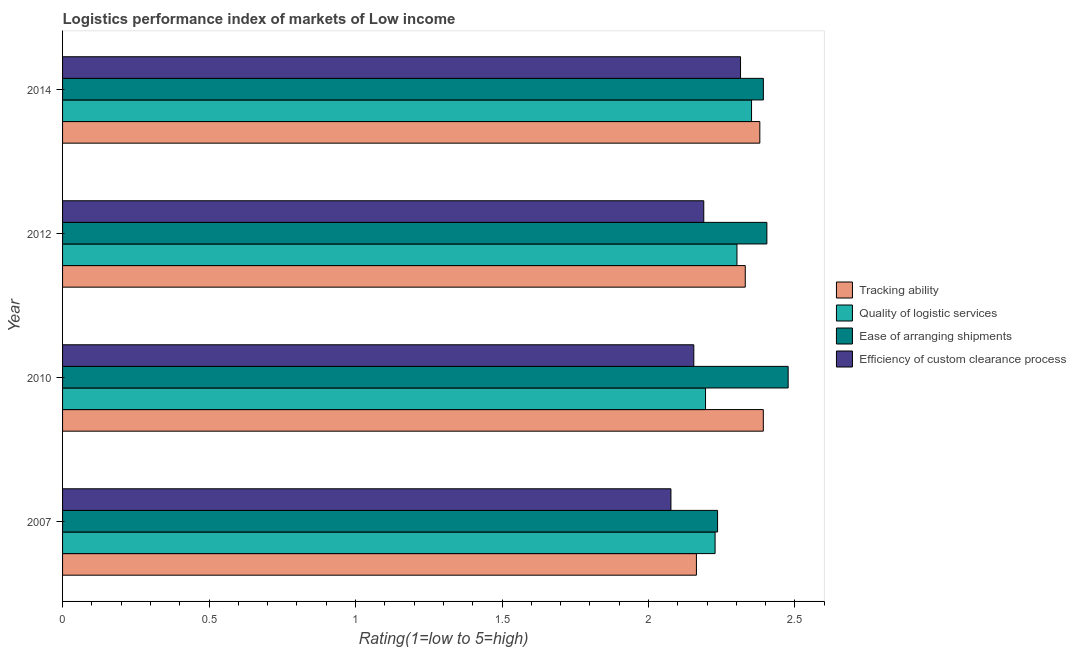Are the number of bars on each tick of the Y-axis equal?
Ensure brevity in your answer.  Yes. How many bars are there on the 2nd tick from the top?
Ensure brevity in your answer.  4. How many bars are there on the 1st tick from the bottom?
Offer a very short reply. 4. In how many cases, is the number of bars for a given year not equal to the number of legend labels?
Keep it short and to the point. 0. What is the lpi rating of quality of logistic services in 2010?
Provide a succinct answer. 2.19. Across all years, what is the maximum lpi rating of quality of logistic services?
Your answer should be very brief. 2.35. Across all years, what is the minimum lpi rating of efficiency of custom clearance process?
Offer a terse response. 2.08. In which year was the lpi rating of tracking ability maximum?
Give a very brief answer. 2010. What is the total lpi rating of ease of arranging shipments in the graph?
Keep it short and to the point. 9.51. What is the difference between the lpi rating of ease of arranging shipments in 2010 and the lpi rating of efficiency of custom clearance process in 2007?
Your answer should be very brief. 0.4. What is the average lpi rating of ease of arranging shipments per year?
Keep it short and to the point. 2.38. In the year 2014, what is the difference between the lpi rating of efficiency of custom clearance process and lpi rating of tracking ability?
Offer a very short reply. -0.07. In how many years, is the lpi rating of ease of arranging shipments greater than 0.2 ?
Offer a very short reply. 4. Is the lpi rating of quality of logistic services in 2010 less than that in 2012?
Your answer should be very brief. Yes. Is the difference between the lpi rating of tracking ability in 2007 and 2010 greater than the difference between the lpi rating of efficiency of custom clearance process in 2007 and 2010?
Provide a short and direct response. No. What is the difference between the highest and the second highest lpi rating of ease of arranging shipments?
Provide a succinct answer. 0.07. What is the difference between the highest and the lowest lpi rating of quality of logistic services?
Ensure brevity in your answer.  0.16. In how many years, is the lpi rating of efficiency of custom clearance process greater than the average lpi rating of efficiency of custom clearance process taken over all years?
Your answer should be very brief. 2. Is the sum of the lpi rating of quality of logistic services in 2012 and 2014 greater than the maximum lpi rating of tracking ability across all years?
Offer a terse response. Yes. What does the 3rd bar from the top in 2012 represents?
Your answer should be very brief. Quality of logistic services. What does the 3rd bar from the bottom in 2014 represents?
Provide a succinct answer. Ease of arranging shipments. What is the difference between two consecutive major ticks on the X-axis?
Keep it short and to the point. 0.5. Does the graph contain any zero values?
Offer a terse response. No. Does the graph contain grids?
Offer a terse response. No. How many legend labels are there?
Provide a succinct answer. 4. How are the legend labels stacked?
Provide a short and direct response. Vertical. What is the title of the graph?
Your answer should be very brief. Logistics performance index of markets of Low income. What is the label or title of the X-axis?
Your answer should be very brief. Rating(1=low to 5=high). What is the Rating(1=low to 5=high) of Tracking ability in 2007?
Give a very brief answer. 2.16. What is the Rating(1=low to 5=high) in Quality of logistic services in 2007?
Provide a succinct answer. 2.23. What is the Rating(1=low to 5=high) of Ease of arranging shipments in 2007?
Ensure brevity in your answer.  2.24. What is the Rating(1=low to 5=high) in Efficiency of custom clearance process in 2007?
Your answer should be very brief. 2.08. What is the Rating(1=low to 5=high) of Tracking ability in 2010?
Your answer should be very brief. 2.39. What is the Rating(1=low to 5=high) in Quality of logistic services in 2010?
Ensure brevity in your answer.  2.19. What is the Rating(1=low to 5=high) of Ease of arranging shipments in 2010?
Your response must be concise. 2.48. What is the Rating(1=low to 5=high) of Efficiency of custom clearance process in 2010?
Your answer should be compact. 2.15. What is the Rating(1=low to 5=high) in Tracking ability in 2012?
Provide a succinct answer. 2.33. What is the Rating(1=low to 5=high) in Quality of logistic services in 2012?
Ensure brevity in your answer.  2.3. What is the Rating(1=low to 5=high) of Ease of arranging shipments in 2012?
Keep it short and to the point. 2.4. What is the Rating(1=low to 5=high) of Efficiency of custom clearance process in 2012?
Ensure brevity in your answer.  2.19. What is the Rating(1=low to 5=high) in Tracking ability in 2014?
Your answer should be very brief. 2.38. What is the Rating(1=low to 5=high) of Quality of logistic services in 2014?
Provide a succinct answer. 2.35. What is the Rating(1=low to 5=high) in Ease of arranging shipments in 2014?
Offer a terse response. 2.39. What is the Rating(1=low to 5=high) in Efficiency of custom clearance process in 2014?
Offer a very short reply. 2.31. Across all years, what is the maximum Rating(1=low to 5=high) in Tracking ability?
Provide a succinct answer. 2.39. Across all years, what is the maximum Rating(1=low to 5=high) of Quality of logistic services?
Offer a very short reply. 2.35. Across all years, what is the maximum Rating(1=low to 5=high) of Ease of arranging shipments?
Keep it short and to the point. 2.48. Across all years, what is the maximum Rating(1=low to 5=high) of Efficiency of custom clearance process?
Your response must be concise. 2.31. Across all years, what is the minimum Rating(1=low to 5=high) in Tracking ability?
Keep it short and to the point. 2.16. Across all years, what is the minimum Rating(1=low to 5=high) of Quality of logistic services?
Offer a very short reply. 2.19. Across all years, what is the minimum Rating(1=low to 5=high) of Ease of arranging shipments?
Your response must be concise. 2.24. Across all years, what is the minimum Rating(1=low to 5=high) in Efficiency of custom clearance process?
Provide a short and direct response. 2.08. What is the total Rating(1=low to 5=high) of Tracking ability in the graph?
Provide a succinct answer. 9.27. What is the total Rating(1=low to 5=high) in Quality of logistic services in the graph?
Your response must be concise. 9.08. What is the total Rating(1=low to 5=high) of Ease of arranging shipments in the graph?
Ensure brevity in your answer.  9.51. What is the total Rating(1=low to 5=high) of Efficiency of custom clearance process in the graph?
Your answer should be compact. 8.73. What is the difference between the Rating(1=low to 5=high) in Tracking ability in 2007 and that in 2010?
Your response must be concise. -0.23. What is the difference between the Rating(1=low to 5=high) of Quality of logistic services in 2007 and that in 2010?
Keep it short and to the point. 0.03. What is the difference between the Rating(1=low to 5=high) in Ease of arranging shipments in 2007 and that in 2010?
Keep it short and to the point. -0.24. What is the difference between the Rating(1=low to 5=high) in Efficiency of custom clearance process in 2007 and that in 2010?
Keep it short and to the point. -0.08. What is the difference between the Rating(1=low to 5=high) in Tracking ability in 2007 and that in 2012?
Give a very brief answer. -0.17. What is the difference between the Rating(1=low to 5=high) of Quality of logistic services in 2007 and that in 2012?
Ensure brevity in your answer.  -0.07. What is the difference between the Rating(1=low to 5=high) of Ease of arranging shipments in 2007 and that in 2012?
Offer a terse response. -0.17. What is the difference between the Rating(1=low to 5=high) in Efficiency of custom clearance process in 2007 and that in 2012?
Provide a short and direct response. -0.11. What is the difference between the Rating(1=low to 5=high) in Tracking ability in 2007 and that in 2014?
Make the answer very short. -0.22. What is the difference between the Rating(1=low to 5=high) of Quality of logistic services in 2007 and that in 2014?
Offer a terse response. -0.12. What is the difference between the Rating(1=low to 5=high) in Ease of arranging shipments in 2007 and that in 2014?
Give a very brief answer. -0.16. What is the difference between the Rating(1=low to 5=high) in Efficiency of custom clearance process in 2007 and that in 2014?
Your answer should be very brief. -0.24. What is the difference between the Rating(1=low to 5=high) in Tracking ability in 2010 and that in 2012?
Offer a terse response. 0.06. What is the difference between the Rating(1=low to 5=high) of Quality of logistic services in 2010 and that in 2012?
Provide a short and direct response. -0.11. What is the difference between the Rating(1=low to 5=high) of Ease of arranging shipments in 2010 and that in 2012?
Your response must be concise. 0.07. What is the difference between the Rating(1=low to 5=high) of Efficiency of custom clearance process in 2010 and that in 2012?
Give a very brief answer. -0.03. What is the difference between the Rating(1=low to 5=high) of Tracking ability in 2010 and that in 2014?
Make the answer very short. 0.01. What is the difference between the Rating(1=low to 5=high) of Quality of logistic services in 2010 and that in 2014?
Make the answer very short. -0.16. What is the difference between the Rating(1=low to 5=high) in Ease of arranging shipments in 2010 and that in 2014?
Offer a very short reply. 0.08. What is the difference between the Rating(1=low to 5=high) in Efficiency of custom clearance process in 2010 and that in 2014?
Keep it short and to the point. -0.16. What is the difference between the Rating(1=low to 5=high) of Tracking ability in 2012 and that in 2014?
Provide a succinct answer. -0.05. What is the difference between the Rating(1=low to 5=high) of Quality of logistic services in 2012 and that in 2014?
Give a very brief answer. -0.05. What is the difference between the Rating(1=low to 5=high) in Ease of arranging shipments in 2012 and that in 2014?
Give a very brief answer. 0.01. What is the difference between the Rating(1=low to 5=high) in Efficiency of custom clearance process in 2012 and that in 2014?
Your answer should be compact. -0.13. What is the difference between the Rating(1=low to 5=high) in Tracking ability in 2007 and the Rating(1=low to 5=high) in Quality of logistic services in 2010?
Your answer should be compact. -0.03. What is the difference between the Rating(1=low to 5=high) of Tracking ability in 2007 and the Rating(1=low to 5=high) of Ease of arranging shipments in 2010?
Ensure brevity in your answer.  -0.31. What is the difference between the Rating(1=low to 5=high) of Tracking ability in 2007 and the Rating(1=low to 5=high) of Efficiency of custom clearance process in 2010?
Ensure brevity in your answer.  0.01. What is the difference between the Rating(1=low to 5=high) of Quality of logistic services in 2007 and the Rating(1=low to 5=high) of Ease of arranging shipments in 2010?
Keep it short and to the point. -0.25. What is the difference between the Rating(1=low to 5=high) of Quality of logistic services in 2007 and the Rating(1=low to 5=high) of Efficiency of custom clearance process in 2010?
Offer a very short reply. 0.07. What is the difference between the Rating(1=low to 5=high) in Ease of arranging shipments in 2007 and the Rating(1=low to 5=high) in Efficiency of custom clearance process in 2010?
Offer a terse response. 0.08. What is the difference between the Rating(1=low to 5=high) in Tracking ability in 2007 and the Rating(1=low to 5=high) in Quality of logistic services in 2012?
Ensure brevity in your answer.  -0.14. What is the difference between the Rating(1=low to 5=high) of Tracking ability in 2007 and the Rating(1=low to 5=high) of Ease of arranging shipments in 2012?
Your answer should be very brief. -0.24. What is the difference between the Rating(1=low to 5=high) of Tracking ability in 2007 and the Rating(1=low to 5=high) of Efficiency of custom clearance process in 2012?
Offer a terse response. -0.03. What is the difference between the Rating(1=low to 5=high) in Quality of logistic services in 2007 and the Rating(1=low to 5=high) in Ease of arranging shipments in 2012?
Offer a very short reply. -0.18. What is the difference between the Rating(1=low to 5=high) of Quality of logistic services in 2007 and the Rating(1=low to 5=high) of Efficiency of custom clearance process in 2012?
Your response must be concise. 0.04. What is the difference between the Rating(1=low to 5=high) of Ease of arranging shipments in 2007 and the Rating(1=low to 5=high) of Efficiency of custom clearance process in 2012?
Offer a very short reply. 0.05. What is the difference between the Rating(1=low to 5=high) of Tracking ability in 2007 and the Rating(1=low to 5=high) of Quality of logistic services in 2014?
Offer a very short reply. -0.19. What is the difference between the Rating(1=low to 5=high) in Tracking ability in 2007 and the Rating(1=low to 5=high) in Ease of arranging shipments in 2014?
Offer a terse response. -0.23. What is the difference between the Rating(1=low to 5=high) of Tracking ability in 2007 and the Rating(1=low to 5=high) of Efficiency of custom clearance process in 2014?
Make the answer very short. -0.15. What is the difference between the Rating(1=low to 5=high) of Quality of logistic services in 2007 and the Rating(1=low to 5=high) of Ease of arranging shipments in 2014?
Your response must be concise. -0.16. What is the difference between the Rating(1=low to 5=high) in Quality of logistic services in 2007 and the Rating(1=low to 5=high) in Efficiency of custom clearance process in 2014?
Your answer should be very brief. -0.09. What is the difference between the Rating(1=low to 5=high) in Ease of arranging shipments in 2007 and the Rating(1=low to 5=high) in Efficiency of custom clearance process in 2014?
Your answer should be very brief. -0.08. What is the difference between the Rating(1=low to 5=high) of Tracking ability in 2010 and the Rating(1=low to 5=high) of Quality of logistic services in 2012?
Provide a short and direct response. 0.09. What is the difference between the Rating(1=low to 5=high) in Tracking ability in 2010 and the Rating(1=low to 5=high) in Ease of arranging shipments in 2012?
Your answer should be compact. -0.01. What is the difference between the Rating(1=low to 5=high) of Tracking ability in 2010 and the Rating(1=low to 5=high) of Efficiency of custom clearance process in 2012?
Offer a very short reply. 0.2. What is the difference between the Rating(1=low to 5=high) in Quality of logistic services in 2010 and the Rating(1=low to 5=high) in Ease of arranging shipments in 2012?
Provide a short and direct response. -0.21. What is the difference between the Rating(1=low to 5=high) in Quality of logistic services in 2010 and the Rating(1=low to 5=high) in Efficiency of custom clearance process in 2012?
Offer a very short reply. 0.01. What is the difference between the Rating(1=low to 5=high) in Ease of arranging shipments in 2010 and the Rating(1=low to 5=high) in Efficiency of custom clearance process in 2012?
Offer a very short reply. 0.29. What is the difference between the Rating(1=low to 5=high) of Tracking ability in 2010 and the Rating(1=low to 5=high) of Quality of logistic services in 2014?
Your answer should be very brief. 0.04. What is the difference between the Rating(1=low to 5=high) in Tracking ability in 2010 and the Rating(1=low to 5=high) in Ease of arranging shipments in 2014?
Offer a very short reply. -0. What is the difference between the Rating(1=low to 5=high) in Tracking ability in 2010 and the Rating(1=low to 5=high) in Efficiency of custom clearance process in 2014?
Provide a succinct answer. 0.08. What is the difference between the Rating(1=low to 5=high) in Quality of logistic services in 2010 and the Rating(1=low to 5=high) in Ease of arranging shipments in 2014?
Offer a terse response. -0.2. What is the difference between the Rating(1=low to 5=high) in Quality of logistic services in 2010 and the Rating(1=low to 5=high) in Efficiency of custom clearance process in 2014?
Make the answer very short. -0.12. What is the difference between the Rating(1=low to 5=high) of Ease of arranging shipments in 2010 and the Rating(1=low to 5=high) of Efficiency of custom clearance process in 2014?
Your answer should be compact. 0.16. What is the difference between the Rating(1=low to 5=high) of Tracking ability in 2012 and the Rating(1=low to 5=high) of Quality of logistic services in 2014?
Give a very brief answer. -0.02. What is the difference between the Rating(1=low to 5=high) of Tracking ability in 2012 and the Rating(1=low to 5=high) of Ease of arranging shipments in 2014?
Your answer should be compact. -0.06. What is the difference between the Rating(1=low to 5=high) of Tracking ability in 2012 and the Rating(1=low to 5=high) of Efficiency of custom clearance process in 2014?
Ensure brevity in your answer.  0.02. What is the difference between the Rating(1=low to 5=high) in Quality of logistic services in 2012 and the Rating(1=low to 5=high) in Ease of arranging shipments in 2014?
Provide a short and direct response. -0.09. What is the difference between the Rating(1=low to 5=high) in Quality of logistic services in 2012 and the Rating(1=low to 5=high) in Efficiency of custom clearance process in 2014?
Provide a short and direct response. -0.01. What is the difference between the Rating(1=low to 5=high) of Ease of arranging shipments in 2012 and the Rating(1=low to 5=high) of Efficiency of custom clearance process in 2014?
Make the answer very short. 0.09. What is the average Rating(1=low to 5=high) of Tracking ability per year?
Provide a succinct answer. 2.32. What is the average Rating(1=low to 5=high) of Quality of logistic services per year?
Provide a succinct answer. 2.27. What is the average Rating(1=low to 5=high) of Ease of arranging shipments per year?
Offer a terse response. 2.38. What is the average Rating(1=low to 5=high) in Efficiency of custom clearance process per year?
Your answer should be compact. 2.18. In the year 2007, what is the difference between the Rating(1=low to 5=high) in Tracking ability and Rating(1=low to 5=high) in Quality of logistic services?
Make the answer very short. -0.06. In the year 2007, what is the difference between the Rating(1=low to 5=high) in Tracking ability and Rating(1=low to 5=high) in Ease of arranging shipments?
Give a very brief answer. -0.07. In the year 2007, what is the difference between the Rating(1=low to 5=high) of Tracking ability and Rating(1=low to 5=high) of Efficiency of custom clearance process?
Offer a very short reply. 0.09. In the year 2007, what is the difference between the Rating(1=low to 5=high) of Quality of logistic services and Rating(1=low to 5=high) of Ease of arranging shipments?
Provide a succinct answer. -0.01. In the year 2007, what is the difference between the Rating(1=low to 5=high) in Quality of logistic services and Rating(1=low to 5=high) in Efficiency of custom clearance process?
Keep it short and to the point. 0.15. In the year 2007, what is the difference between the Rating(1=low to 5=high) of Ease of arranging shipments and Rating(1=low to 5=high) of Efficiency of custom clearance process?
Make the answer very short. 0.16. In the year 2010, what is the difference between the Rating(1=low to 5=high) in Tracking ability and Rating(1=low to 5=high) in Quality of logistic services?
Provide a short and direct response. 0.2. In the year 2010, what is the difference between the Rating(1=low to 5=high) of Tracking ability and Rating(1=low to 5=high) of Ease of arranging shipments?
Offer a very short reply. -0.08. In the year 2010, what is the difference between the Rating(1=low to 5=high) in Tracking ability and Rating(1=low to 5=high) in Efficiency of custom clearance process?
Your answer should be compact. 0.24. In the year 2010, what is the difference between the Rating(1=low to 5=high) of Quality of logistic services and Rating(1=low to 5=high) of Ease of arranging shipments?
Your response must be concise. -0.28. In the year 2010, what is the difference between the Rating(1=low to 5=high) in Ease of arranging shipments and Rating(1=low to 5=high) in Efficiency of custom clearance process?
Your answer should be compact. 0.32. In the year 2012, what is the difference between the Rating(1=low to 5=high) in Tracking ability and Rating(1=low to 5=high) in Quality of logistic services?
Keep it short and to the point. 0.03. In the year 2012, what is the difference between the Rating(1=low to 5=high) of Tracking ability and Rating(1=low to 5=high) of Ease of arranging shipments?
Make the answer very short. -0.07. In the year 2012, what is the difference between the Rating(1=low to 5=high) of Tracking ability and Rating(1=low to 5=high) of Efficiency of custom clearance process?
Offer a terse response. 0.14. In the year 2012, what is the difference between the Rating(1=low to 5=high) in Quality of logistic services and Rating(1=low to 5=high) in Ease of arranging shipments?
Ensure brevity in your answer.  -0.1. In the year 2012, what is the difference between the Rating(1=low to 5=high) of Quality of logistic services and Rating(1=low to 5=high) of Efficiency of custom clearance process?
Give a very brief answer. 0.11. In the year 2012, what is the difference between the Rating(1=low to 5=high) of Ease of arranging shipments and Rating(1=low to 5=high) of Efficiency of custom clearance process?
Your answer should be compact. 0.22. In the year 2014, what is the difference between the Rating(1=low to 5=high) of Tracking ability and Rating(1=low to 5=high) of Quality of logistic services?
Offer a very short reply. 0.03. In the year 2014, what is the difference between the Rating(1=low to 5=high) in Tracking ability and Rating(1=low to 5=high) in Ease of arranging shipments?
Ensure brevity in your answer.  -0.01. In the year 2014, what is the difference between the Rating(1=low to 5=high) of Tracking ability and Rating(1=low to 5=high) of Efficiency of custom clearance process?
Keep it short and to the point. 0.07. In the year 2014, what is the difference between the Rating(1=low to 5=high) of Quality of logistic services and Rating(1=low to 5=high) of Ease of arranging shipments?
Provide a short and direct response. -0.04. In the year 2014, what is the difference between the Rating(1=low to 5=high) of Quality of logistic services and Rating(1=low to 5=high) of Efficiency of custom clearance process?
Keep it short and to the point. 0.04. In the year 2014, what is the difference between the Rating(1=low to 5=high) of Ease of arranging shipments and Rating(1=low to 5=high) of Efficiency of custom clearance process?
Provide a short and direct response. 0.08. What is the ratio of the Rating(1=low to 5=high) of Tracking ability in 2007 to that in 2010?
Your response must be concise. 0.9. What is the ratio of the Rating(1=low to 5=high) of Quality of logistic services in 2007 to that in 2010?
Offer a very short reply. 1.01. What is the ratio of the Rating(1=low to 5=high) in Ease of arranging shipments in 2007 to that in 2010?
Your answer should be compact. 0.9. What is the ratio of the Rating(1=low to 5=high) of Efficiency of custom clearance process in 2007 to that in 2010?
Provide a succinct answer. 0.96. What is the ratio of the Rating(1=low to 5=high) of Tracking ability in 2007 to that in 2012?
Make the answer very short. 0.93. What is the ratio of the Rating(1=low to 5=high) of Quality of logistic services in 2007 to that in 2012?
Keep it short and to the point. 0.97. What is the ratio of the Rating(1=low to 5=high) in Ease of arranging shipments in 2007 to that in 2012?
Provide a short and direct response. 0.93. What is the ratio of the Rating(1=low to 5=high) of Efficiency of custom clearance process in 2007 to that in 2012?
Provide a succinct answer. 0.95. What is the ratio of the Rating(1=low to 5=high) in Quality of logistic services in 2007 to that in 2014?
Your response must be concise. 0.95. What is the ratio of the Rating(1=low to 5=high) in Ease of arranging shipments in 2007 to that in 2014?
Keep it short and to the point. 0.93. What is the ratio of the Rating(1=low to 5=high) of Efficiency of custom clearance process in 2007 to that in 2014?
Keep it short and to the point. 0.9. What is the ratio of the Rating(1=low to 5=high) in Tracking ability in 2010 to that in 2012?
Your response must be concise. 1.03. What is the ratio of the Rating(1=low to 5=high) in Quality of logistic services in 2010 to that in 2012?
Offer a terse response. 0.95. What is the ratio of the Rating(1=low to 5=high) of Ease of arranging shipments in 2010 to that in 2012?
Provide a short and direct response. 1.03. What is the ratio of the Rating(1=low to 5=high) of Efficiency of custom clearance process in 2010 to that in 2012?
Provide a succinct answer. 0.98. What is the ratio of the Rating(1=low to 5=high) in Tracking ability in 2010 to that in 2014?
Ensure brevity in your answer.  1. What is the ratio of the Rating(1=low to 5=high) in Quality of logistic services in 2010 to that in 2014?
Provide a succinct answer. 0.93. What is the ratio of the Rating(1=low to 5=high) in Ease of arranging shipments in 2010 to that in 2014?
Your answer should be very brief. 1.04. What is the ratio of the Rating(1=low to 5=high) of Efficiency of custom clearance process in 2010 to that in 2014?
Ensure brevity in your answer.  0.93. What is the ratio of the Rating(1=low to 5=high) of Tracking ability in 2012 to that in 2014?
Offer a terse response. 0.98. What is the ratio of the Rating(1=low to 5=high) of Quality of logistic services in 2012 to that in 2014?
Your answer should be compact. 0.98. What is the ratio of the Rating(1=low to 5=high) of Ease of arranging shipments in 2012 to that in 2014?
Ensure brevity in your answer.  1. What is the ratio of the Rating(1=low to 5=high) of Efficiency of custom clearance process in 2012 to that in 2014?
Offer a terse response. 0.95. What is the difference between the highest and the second highest Rating(1=low to 5=high) of Tracking ability?
Offer a terse response. 0.01. What is the difference between the highest and the second highest Rating(1=low to 5=high) in Quality of logistic services?
Provide a short and direct response. 0.05. What is the difference between the highest and the second highest Rating(1=low to 5=high) in Ease of arranging shipments?
Provide a succinct answer. 0.07. What is the difference between the highest and the second highest Rating(1=low to 5=high) of Efficiency of custom clearance process?
Your response must be concise. 0.13. What is the difference between the highest and the lowest Rating(1=low to 5=high) in Tracking ability?
Your answer should be very brief. 0.23. What is the difference between the highest and the lowest Rating(1=low to 5=high) in Quality of logistic services?
Provide a short and direct response. 0.16. What is the difference between the highest and the lowest Rating(1=low to 5=high) of Ease of arranging shipments?
Provide a short and direct response. 0.24. What is the difference between the highest and the lowest Rating(1=low to 5=high) in Efficiency of custom clearance process?
Offer a terse response. 0.24. 